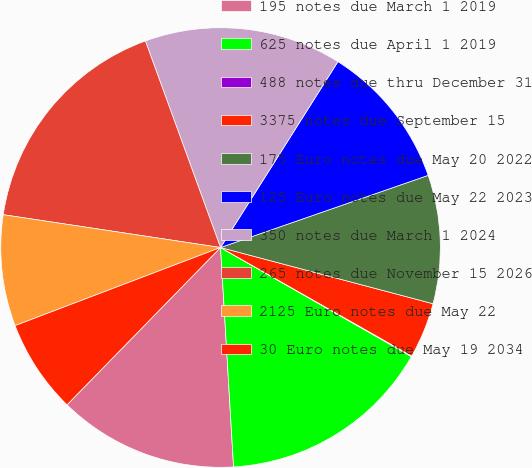<chart> <loc_0><loc_0><loc_500><loc_500><pie_chart><fcel>195 notes due March 1 2019<fcel>625 notes due April 1 2019<fcel>488 notes due thru December 31<fcel>3375 notes due September 15<fcel>175 Euro notes due May 20 2022<fcel>125 Euro notes due May 22 2023<fcel>350 notes due March 1 2024<fcel>265 notes due November 15 2026<fcel>2125 Euro notes due May 22<fcel>30 Euro notes due May 19 2034<nl><fcel>13.25%<fcel>15.79%<fcel>0.05%<fcel>4.1%<fcel>9.44%<fcel>10.71%<fcel>14.52%<fcel>17.06%<fcel>8.17%<fcel>6.91%<nl></chart> 